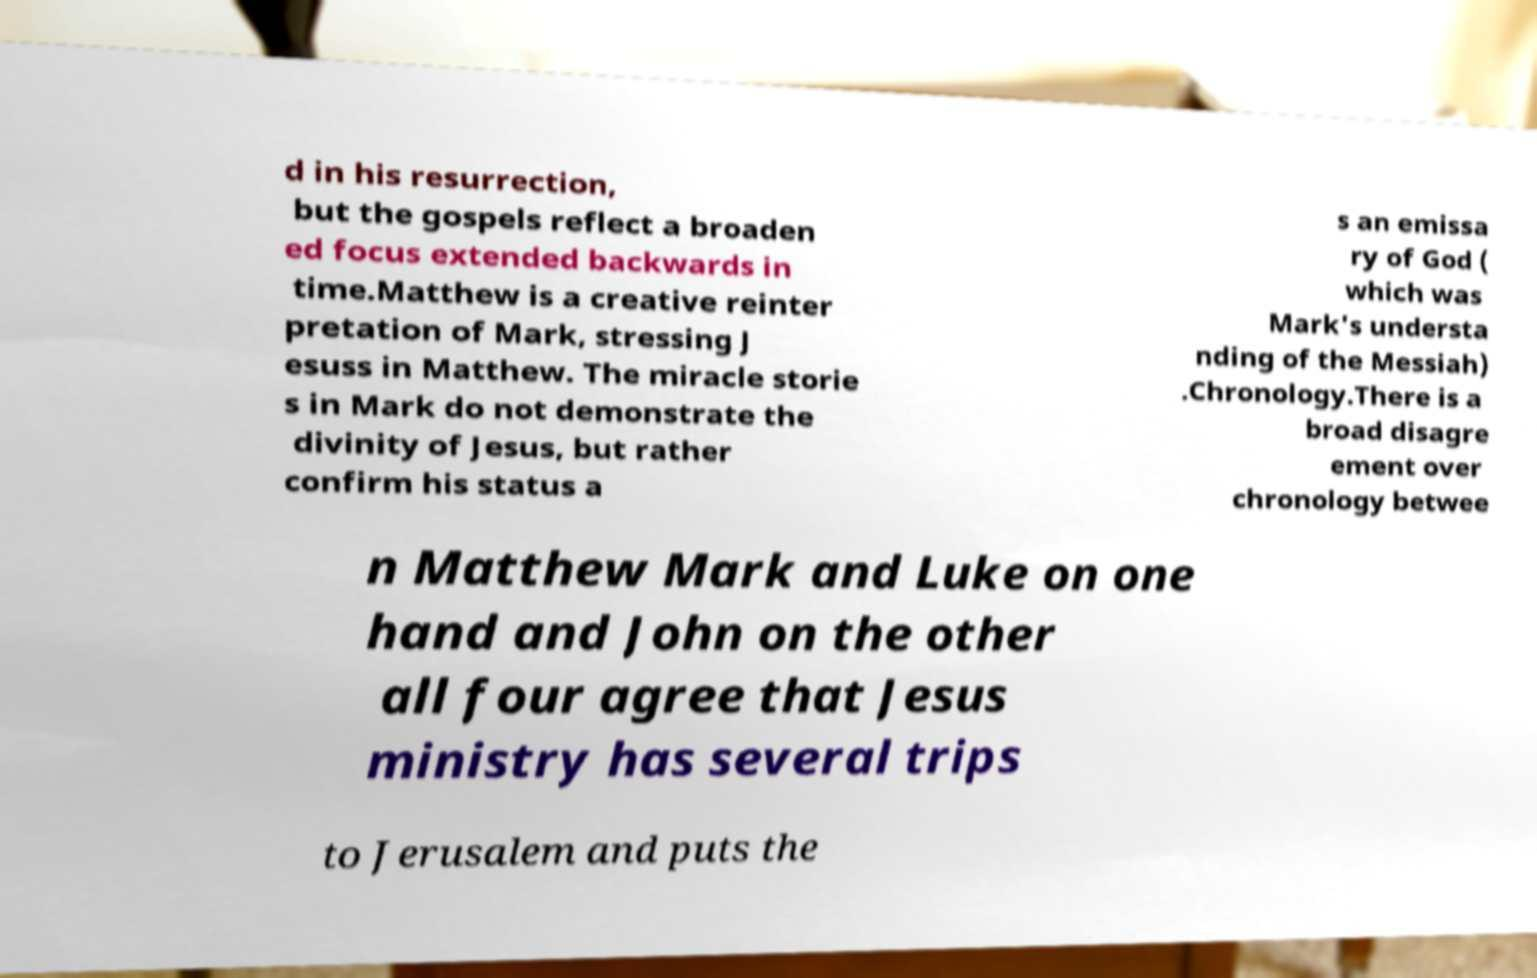I need the written content from this picture converted into text. Can you do that? d in his resurrection, but the gospels reflect a broaden ed focus extended backwards in time.Matthew is a creative reinter pretation of Mark, stressing J esuss in Matthew. The miracle storie s in Mark do not demonstrate the divinity of Jesus, but rather confirm his status a s an emissa ry of God ( which was Mark's understa nding of the Messiah) .Chronology.There is a broad disagre ement over chronology betwee n Matthew Mark and Luke on one hand and John on the other all four agree that Jesus ministry has several trips to Jerusalem and puts the 